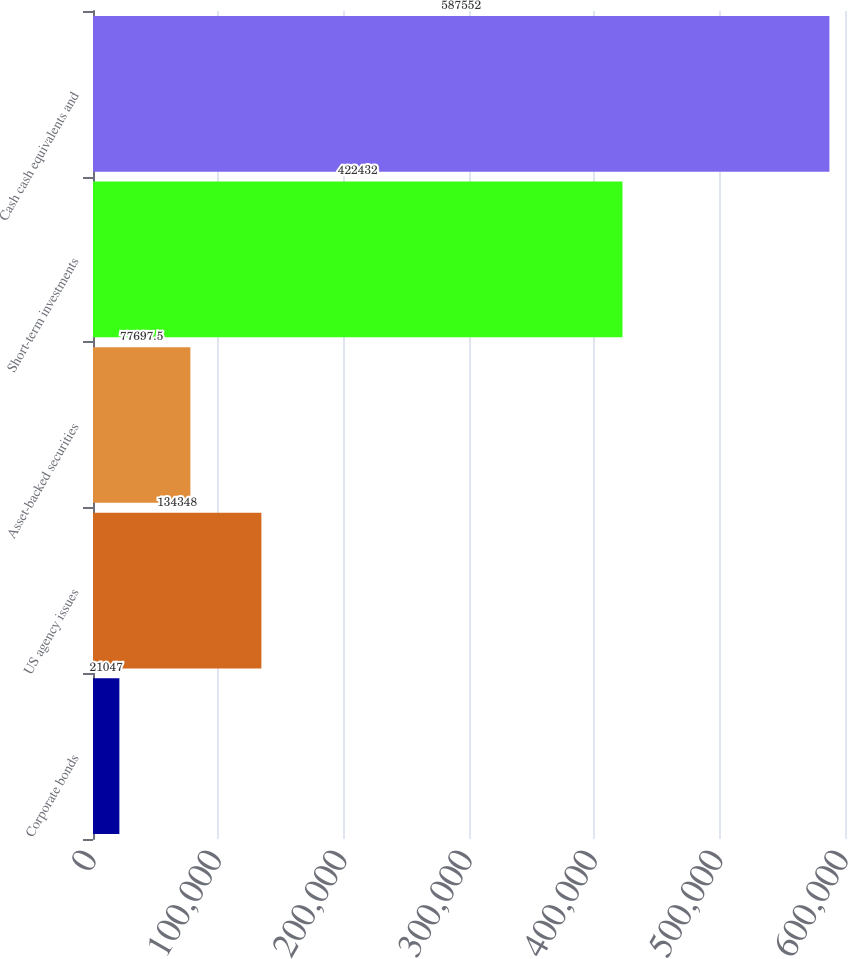<chart> <loc_0><loc_0><loc_500><loc_500><bar_chart><fcel>Corporate bonds<fcel>US agency issues<fcel>Asset-backed securities<fcel>Short-term investments<fcel>Cash cash equivalents and<nl><fcel>21047<fcel>134348<fcel>77697.5<fcel>422432<fcel>587552<nl></chart> 